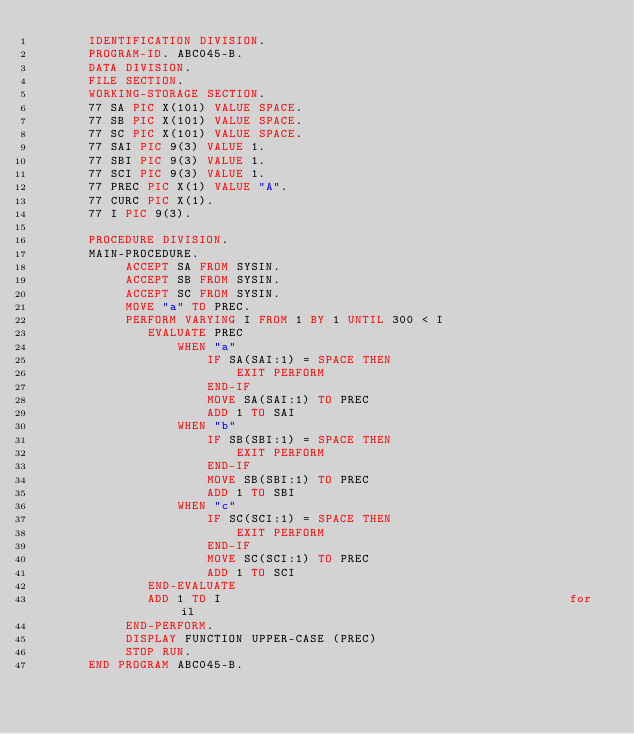<code> <loc_0><loc_0><loc_500><loc_500><_COBOL_>       IDENTIFICATION DIVISION.
       PROGRAM-ID. ABC045-B.
       DATA DIVISION.
       FILE SECTION.
       WORKING-STORAGE SECTION.
       77 SA PIC X(101) VALUE SPACE.
       77 SB PIC X(101) VALUE SPACE.
       77 SC PIC X(101) VALUE SPACE.
       77 SAI PIC 9(3) VALUE 1.
       77 SBI PIC 9(3) VALUE 1.
       77 SCI PIC 9(3) VALUE 1.
       77 PREC PIC X(1) VALUE "A".
       77 CURC PIC X(1).
       77 I PIC 9(3).

       PROCEDURE DIVISION.
       MAIN-PROCEDURE.
            ACCEPT SA FROM SYSIN.
            ACCEPT SB FROM SYSIN.
            ACCEPT SC FROM SYSIN.
            MOVE "a" TO PREC.
            PERFORM VARYING I FROM 1 BY 1 UNTIL 300 < I
               EVALUATE PREC
                   WHEN "a"
                       IF SA(SAI:1) = SPACE THEN
                           EXIT PERFORM
                       END-IF
                       MOVE SA(SAI:1) TO PREC
                       ADD 1 TO SAI
                   WHEN "b"
                       IF SB(SBI:1) = SPACE THEN
                           EXIT PERFORM
                       END-IF
                       MOVE SB(SBI:1) TO PREC
                       ADD 1 TO SBI
                   WHEN "c"
                       IF SC(SCI:1) = SPACE THEN
                           EXIT PERFORM
                       END-IF
                       MOVE SC(SCI:1) TO PREC
                       ADD 1 TO SCI
               END-EVALUATE
               ADD 1 TO I                                               for il
            END-PERFORM.
            DISPLAY FUNCTION UPPER-CASE (PREC)
            STOP RUN.
       END PROGRAM ABC045-B.
</code> 